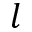Convert formula to latex. <formula><loc_0><loc_0><loc_500><loc_500>l</formula> 